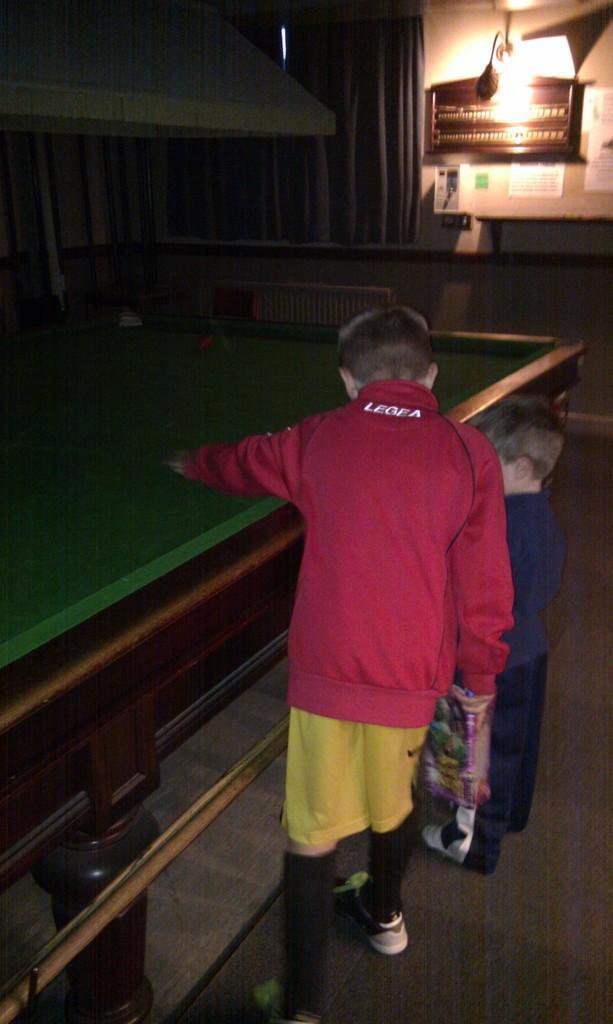Please provide a concise description of this image. In this image i can see there are two children standing on the floor on the side of a snooker table. 